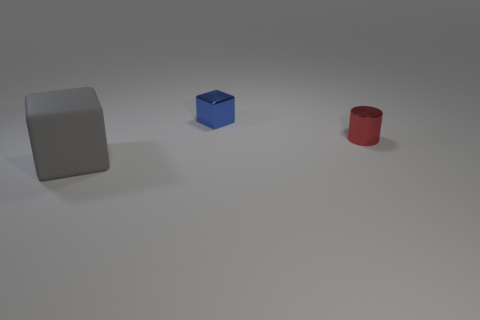Is there any other thing that has the same size as the gray object?
Offer a very short reply. No. There is a object that is in front of the tiny metal object in front of the small block; how big is it?
Your response must be concise. Large. What color is the metal thing on the left side of the metallic object that is in front of the shiny thing that is on the left side of the tiny red shiny thing?
Provide a short and direct response. Blue. There is a object that is both in front of the small metallic cube and behind the big cube; how big is it?
Provide a succinct answer. Small. How many other objects are there of the same shape as the small red metal object?
Offer a terse response. 0. What number of balls are large red rubber things or blue things?
Keep it short and to the point. 0. There is a cube on the right side of the big gray rubber thing that is to the left of the blue thing; is there a thing that is to the left of it?
Ensure brevity in your answer.  Yes. What is the color of the big matte object that is the same shape as the small blue shiny object?
Your answer should be very brief. Gray. What number of red objects are either large objects or tiny cylinders?
Ensure brevity in your answer.  1. There is a cube on the left side of the block that is behind the tiny red metallic cylinder; what is it made of?
Your answer should be very brief. Rubber. 